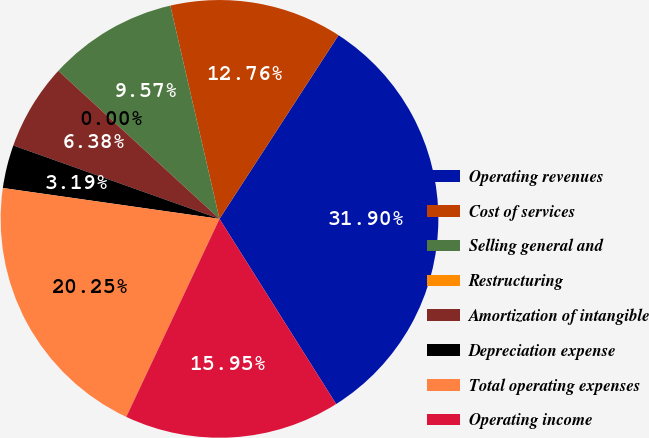Convert chart to OTSL. <chart><loc_0><loc_0><loc_500><loc_500><pie_chart><fcel>Operating revenues<fcel>Cost of services<fcel>Selling general and<fcel>Restructuring<fcel>Amortization of intangible<fcel>Depreciation expense<fcel>Total operating expenses<fcel>Operating income<nl><fcel>31.9%<fcel>12.76%<fcel>9.57%<fcel>0.0%<fcel>6.38%<fcel>3.19%<fcel>20.25%<fcel>15.95%<nl></chart> 